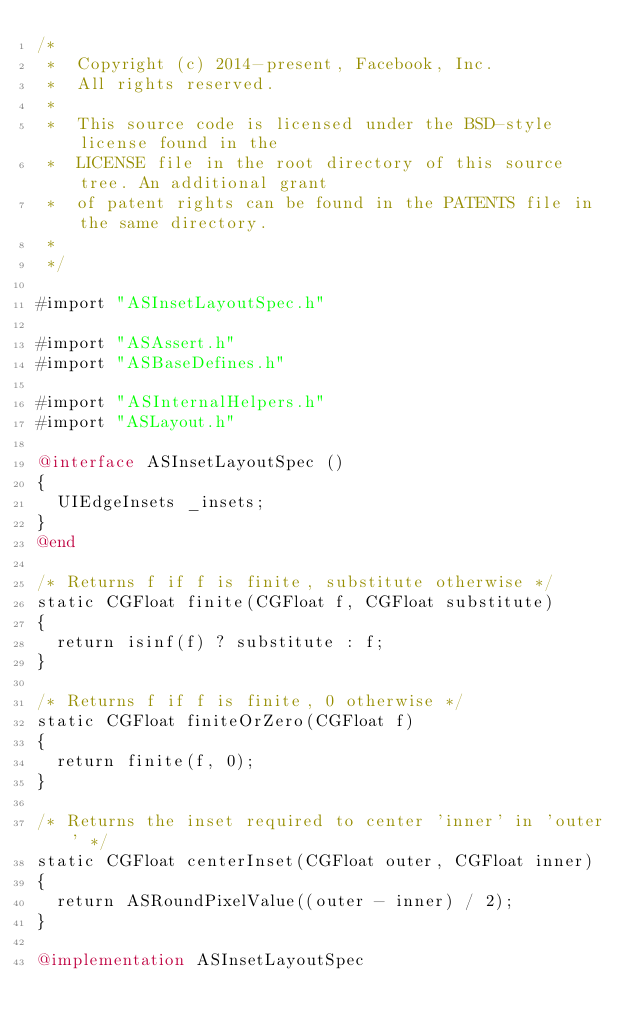Convert code to text. <code><loc_0><loc_0><loc_500><loc_500><_ObjectiveC_>/*
 *  Copyright (c) 2014-present, Facebook, Inc.
 *  All rights reserved.
 *
 *  This source code is licensed under the BSD-style license found in the
 *  LICENSE file in the root directory of this source tree. An additional grant
 *  of patent rights can be found in the PATENTS file in the same directory.
 *
 */

#import "ASInsetLayoutSpec.h"

#import "ASAssert.h"
#import "ASBaseDefines.h"

#import "ASInternalHelpers.h"
#import "ASLayout.h"

@interface ASInsetLayoutSpec ()
{
  UIEdgeInsets _insets;
}
@end

/* Returns f if f is finite, substitute otherwise */
static CGFloat finite(CGFloat f, CGFloat substitute)
{
  return isinf(f) ? substitute : f;
}

/* Returns f if f is finite, 0 otherwise */
static CGFloat finiteOrZero(CGFloat f)
{
  return finite(f, 0);
}

/* Returns the inset required to center 'inner' in 'outer' */
static CGFloat centerInset(CGFloat outer, CGFloat inner)
{
  return ASRoundPixelValue((outer - inner) / 2);
}

@implementation ASInsetLayoutSpec
</code> 